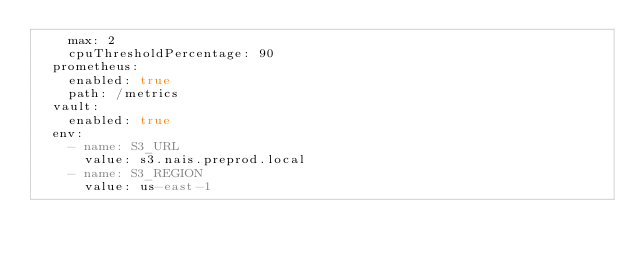<code> <loc_0><loc_0><loc_500><loc_500><_YAML_>    max: 2
    cpuThresholdPercentage: 90
  prometheus:
    enabled: true
    path: /metrics
  vault:
    enabled: true
  env:
    - name: S3_URL
      value: s3.nais.preprod.local
    - name: S3_REGION
      value: us-east-1
</code> 